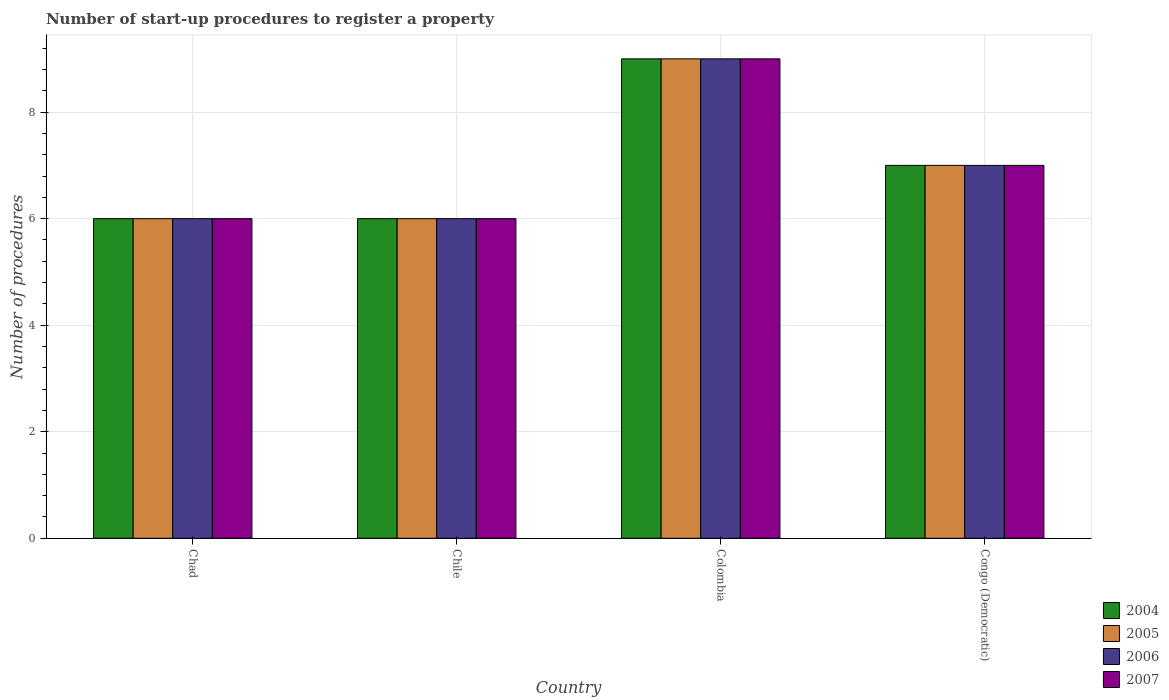How many groups of bars are there?
Offer a very short reply. 4. Are the number of bars per tick equal to the number of legend labels?
Your response must be concise. Yes. Are the number of bars on each tick of the X-axis equal?
Provide a short and direct response. Yes. How many bars are there on the 2nd tick from the right?
Keep it short and to the point. 4. Across all countries, what is the minimum number of procedures required to register a property in 2006?
Provide a succinct answer. 6. In which country was the number of procedures required to register a property in 2007 maximum?
Ensure brevity in your answer.  Colombia. In which country was the number of procedures required to register a property in 2004 minimum?
Offer a very short reply. Chad. What is the difference between the number of procedures required to register a property in 2006 in Chad and that in Colombia?
Provide a succinct answer. -3. What is the difference between the number of procedures required to register a property of/in 2006 and number of procedures required to register a property of/in 2007 in Colombia?
Your answer should be very brief. 0. What is the ratio of the number of procedures required to register a property in 2007 in Chad to that in Colombia?
Keep it short and to the point. 0.67. Is the number of procedures required to register a property in 2007 in Chad less than that in Chile?
Provide a succinct answer. No. What is the difference between the highest and the second highest number of procedures required to register a property in 2006?
Offer a very short reply. 3. What is the difference between the highest and the lowest number of procedures required to register a property in 2006?
Your response must be concise. 3. In how many countries, is the number of procedures required to register a property in 2007 greater than the average number of procedures required to register a property in 2007 taken over all countries?
Your answer should be compact. 1. Is it the case that in every country, the sum of the number of procedures required to register a property in 2005 and number of procedures required to register a property in 2004 is greater than the sum of number of procedures required to register a property in 2006 and number of procedures required to register a property in 2007?
Give a very brief answer. No. What does the 2nd bar from the left in Chile represents?
Offer a terse response. 2005. Are the values on the major ticks of Y-axis written in scientific E-notation?
Provide a succinct answer. No. Does the graph contain any zero values?
Keep it short and to the point. No. Does the graph contain grids?
Offer a very short reply. Yes. How are the legend labels stacked?
Your response must be concise. Vertical. What is the title of the graph?
Your answer should be compact. Number of start-up procedures to register a property. Does "1966" appear as one of the legend labels in the graph?
Provide a short and direct response. No. What is the label or title of the X-axis?
Your answer should be very brief. Country. What is the label or title of the Y-axis?
Your answer should be very brief. Number of procedures. What is the Number of procedures in 2005 in Chad?
Your answer should be very brief. 6. What is the Number of procedures of 2006 in Chad?
Provide a succinct answer. 6. What is the Number of procedures in 2005 in Chile?
Ensure brevity in your answer.  6. What is the Number of procedures of 2006 in Chile?
Ensure brevity in your answer.  6. What is the Number of procedures in 2007 in Chile?
Provide a succinct answer. 6. What is the Number of procedures of 2004 in Congo (Democratic)?
Your response must be concise. 7. What is the Number of procedures in 2005 in Congo (Democratic)?
Ensure brevity in your answer.  7. What is the Number of procedures of 2007 in Congo (Democratic)?
Your answer should be compact. 7. Across all countries, what is the maximum Number of procedures of 2005?
Provide a succinct answer. 9. Across all countries, what is the maximum Number of procedures of 2006?
Provide a short and direct response. 9. Across all countries, what is the maximum Number of procedures of 2007?
Offer a very short reply. 9. What is the total Number of procedures in 2004 in the graph?
Offer a very short reply. 28. What is the difference between the Number of procedures in 2004 in Chad and that in Chile?
Your answer should be compact. 0. What is the difference between the Number of procedures in 2005 in Chad and that in Chile?
Ensure brevity in your answer.  0. What is the difference between the Number of procedures of 2007 in Chad and that in Chile?
Ensure brevity in your answer.  0. What is the difference between the Number of procedures of 2005 in Chad and that in Colombia?
Keep it short and to the point. -3. What is the difference between the Number of procedures of 2006 in Chad and that in Colombia?
Keep it short and to the point. -3. What is the difference between the Number of procedures of 2007 in Chad and that in Colombia?
Keep it short and to the point. -3. What is the difference between the Number of procedures in 2007 in Chad and that in Congo (Democratic)?
Offer a terse response. -1. What is the difference between the Number of procedures of 2004 in Chile and that in Colombia?
Offer a terse response. -3. What is the difference between the Number of procedures in 2005 in Chile and that in Colombia?
Provide a succinct answer. -3. What is the difference between the Number of procedures of 2005 in Chile and that in Congo (Democratic)?
Give a very brief answer. -1. What is the difference between the Number of procedures in 2006 in Chile and that in Congo (Democratic)?
Your answer should be compact. -1. What is the difference between the Number of procedures in 2007 in Chile and that in Congo (Democratic)?
Ensure brevity in your answer.  -1. What is the difference between the Number of procedures in 2004 in Colombia and that in Congo (Democratic)?
Ensure brevity in your answer.  2. What is the difference between the Number of procedures in 2006 in Colombia and that in Congo (Democratic)?
Provide a short and direct response. 2. What is the difference between the Number of procedures of 2007 in Colombia and that in Congo (Democratic)?
Provide a succinct answer. 2. What is the difference between the Number of procedures in 2004 in Chad and the Number of procedures in 2005 in Chile?
Ensure brevity in your answer.  0. What is the difference between the Number of procedures in 2005 in Chad and the Number of procedures in 2006 in Chile?
Offer a terse response. 0. What is the difference between the Number of procedures of 2005 in Chad and the Number of procedures of 2007 in Chile?
Your answer should be very brief. 0. What is the difference between the Number of procedures of 2006 in Chad and the Number of procedures of 2007 in Chile?
Your answer should be compact. 0. What is the difference between the Number of procedures of 2004 in Chad and the Number of procedures of 2006 in Colombia?
Offer a terse response. -3. What is the difference between the Number of procedures of 2005 in Chad and the Number of procedures of 2006 in Colombia?
Your answer should be very brief. -3. What is the difference between the Number of procedures of 2006 in Chad and the Number of procedures of 2007 in Colombia?
Offer a terse response. -3. What is the difference between the Number of procedures of 2004 in Chad and the Number of procedures of 2006 in Congo (Democratic)?
Provide a succinct answer. -1. What is the difference between the Number of procedures in 2006 in Chad and the Number of procedures in 2007 in Congo (Democratic)?
Offer a terse response. -1. What is the difference between the Number of procedures in 2004 in Chile and the Number of procedures in 2005 in Colombia?
Provide a short and direct response. -3. What is the difference between the Number of procedures in 2005 in Chile and the Number of procedures in 2007 in Colombia?
Give a very brief answer. -3. What is the difference between the Number of procedures of 2004 in Chile and the Number of procedures of 2006 in Congo (Democratic)?
Give a very brief answer. -1. What is the difference between the Number of procedures of 2004 in Chile and the Number of procedures of 2007 in Congo (Democratic)?
Your response must be concise. -1. What is the difference between the Number of procedures in 2006 in Chile and the Number of procedures in 2007 in Congo (Democratic)?
Offer a terse response. -1. What is the difference between the Number of procedures in 2004 in Colombia and the Number of procedures in 2005 in Congo (Democratic)?
Keep it short and to the point. 2. What is the difference between the Number of procedures of 2006 in Colombia and the Number of procedures of 2007 in Congo (Democratic)?
Ensure brevity in your answer.  2. What is the average Number of procedures in 2006 per country?
Offer a very short reply. 7. What is the average Number of procedures of 2007 per country?
Ensure brevity in your answer.  7. What is the difference between the Number of procedures in 2004 and Number of procedures in 2006 in Chad?
Your response must be concise. 0. What is the difference between the Number of procedures in 2004 and Number of procedures in 2007 in Chad?
Give a very brief answer. 0. What is the difference between the Number of procedures in 2005 and Number of procedures in 2006 in Chad?
Your answer should be very brief. 0. What is the difference between the Number of procedures of 2005 and Number of procedures of 2007 in Chad?
Provide a short and direct response. 0. What is the difference between the Number of procedures in 2006 and Number of procedures in 2007 in Chad?
Provide a short and direct response. 0. What is the difference between the Number of procedures in 2004 and Number of procedures in 2005 in Chile?
Offer a very short reply. 0. What is the difference between the Number of procedures in 2004 and Number of procedures in 2006 in Chile?
Your response must be concise. 0. What is the difference between the Number of procedures of 2006 and Number of procedures of 2007 in Chile?
Offer a very short reply. 0. What is the difference between the Number of procedures in 2004 and Number of procedures in 2007 in Colombia?
Your answer should be compact. 0. What is the difference between the Number of procedures in 2005 and Number of procedures in 2006 in Colombia?
Give a very brief answer. 0. What is the difference between the Number of procedures in 2005 and Number of procedures in 2007 in Colombia?
Offer a very short reply. 0. What is the difference between the Number of procedures of 2006 and Number of procedures of 2007 in Colombia?
Offer a terse response. 0. What is the difference between the Number of procedures of 2004 and Number of procedures of 2005 in Congo (Democratic)?
Give a very brief answer. 0. What is the difference between the Number of procedures in 2005 and Number of procedures in 2006 in Congo (Democratic)?
Your response must be concise. 0. What is the ratio of the Number of procedures in 2004 in Chad to that in Chile?
Your response must be concise. 1. What is the ratio of the Number of procedures of 2007 in Chad to that in Chile?
Offer a terse response. 1. What is the ratio of the Number of procedures in 2006 in Chad to that in Colombia?
Your answer should be very brief. 0.67. What is the ratio of the Number of procedures of 2005 in Chad to that in Congo (Democratic)?
Make the answer very short. 0.86. What is the ratio of the Number of procedures of 2006 in Chad to that in Congo (Democratic)?
Your answer should be very brief. 0.86. What is the ratio of the Number of procedures in 2007 in Chad to that in Congo (Democratic)?
Keep it short and to the point. 0.86. What is the ratio of the Number of procedures of 2004 in Chile to that in Colombia?
Provide a succinct answer. 0.67. What is the ratio of the Number of procedures of 2006 in Chile to that in Colombia?
Keep it short and to the point. 0.67. What is the ratio of the Number of procedures of 2005 in Chile to that in Congo (Democratic)?
Your answer should be compact. 0.86. What is the ratio of the Number of procedures of 2006 in Chile to that in Congo (Democratic)?
Keep it short and to the point. 0.86. What is the ratio of the Number of procedures in 2007 in Chile to that in Congo (Democratic)?
Your answer should be very brief. 0.86. What is the ratio of the Number of procedures in 2005 in Colombia to that in Congo (Democratic)?
Give a very brief answer. 1.29. What is the ratio of the Number of procedures in 2006 in Colombia to that in Congo (Democratic)?
Your response must be concise. 1.29. What is the ratio of the Number of procedures of 2007 in Colombia to that in Congo (Democratic)?
Provide a succinct answer. 1.29. What is the difference between the highest and the second highest Number of procedures in 2005?
Keep it short and to the point. 2. What is the difference between the highest and the lowest Number of procedures in 2005?
Offer a terse response. 3. 